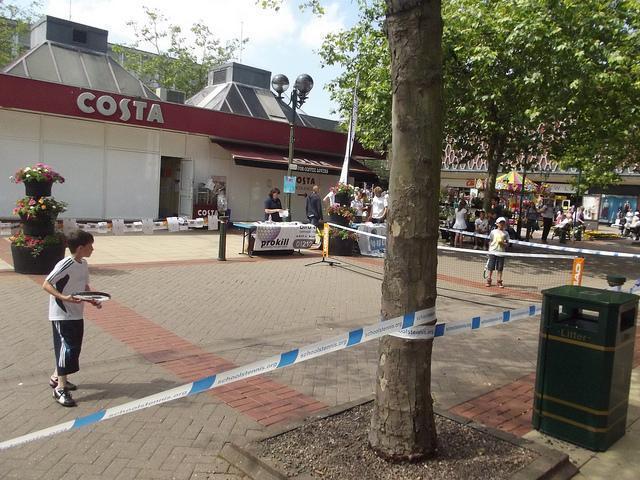What is the boy in the foreground doing?
Pick the right solution, then justify: 'Answer: answer
Rationale: rationale.'
Options: Eating lunch, playing tennis, cleaning park, threatening others. Answer: playing tennis.
Rationale: The boy in the foreground is holding a racquet. he is standing near a net. 